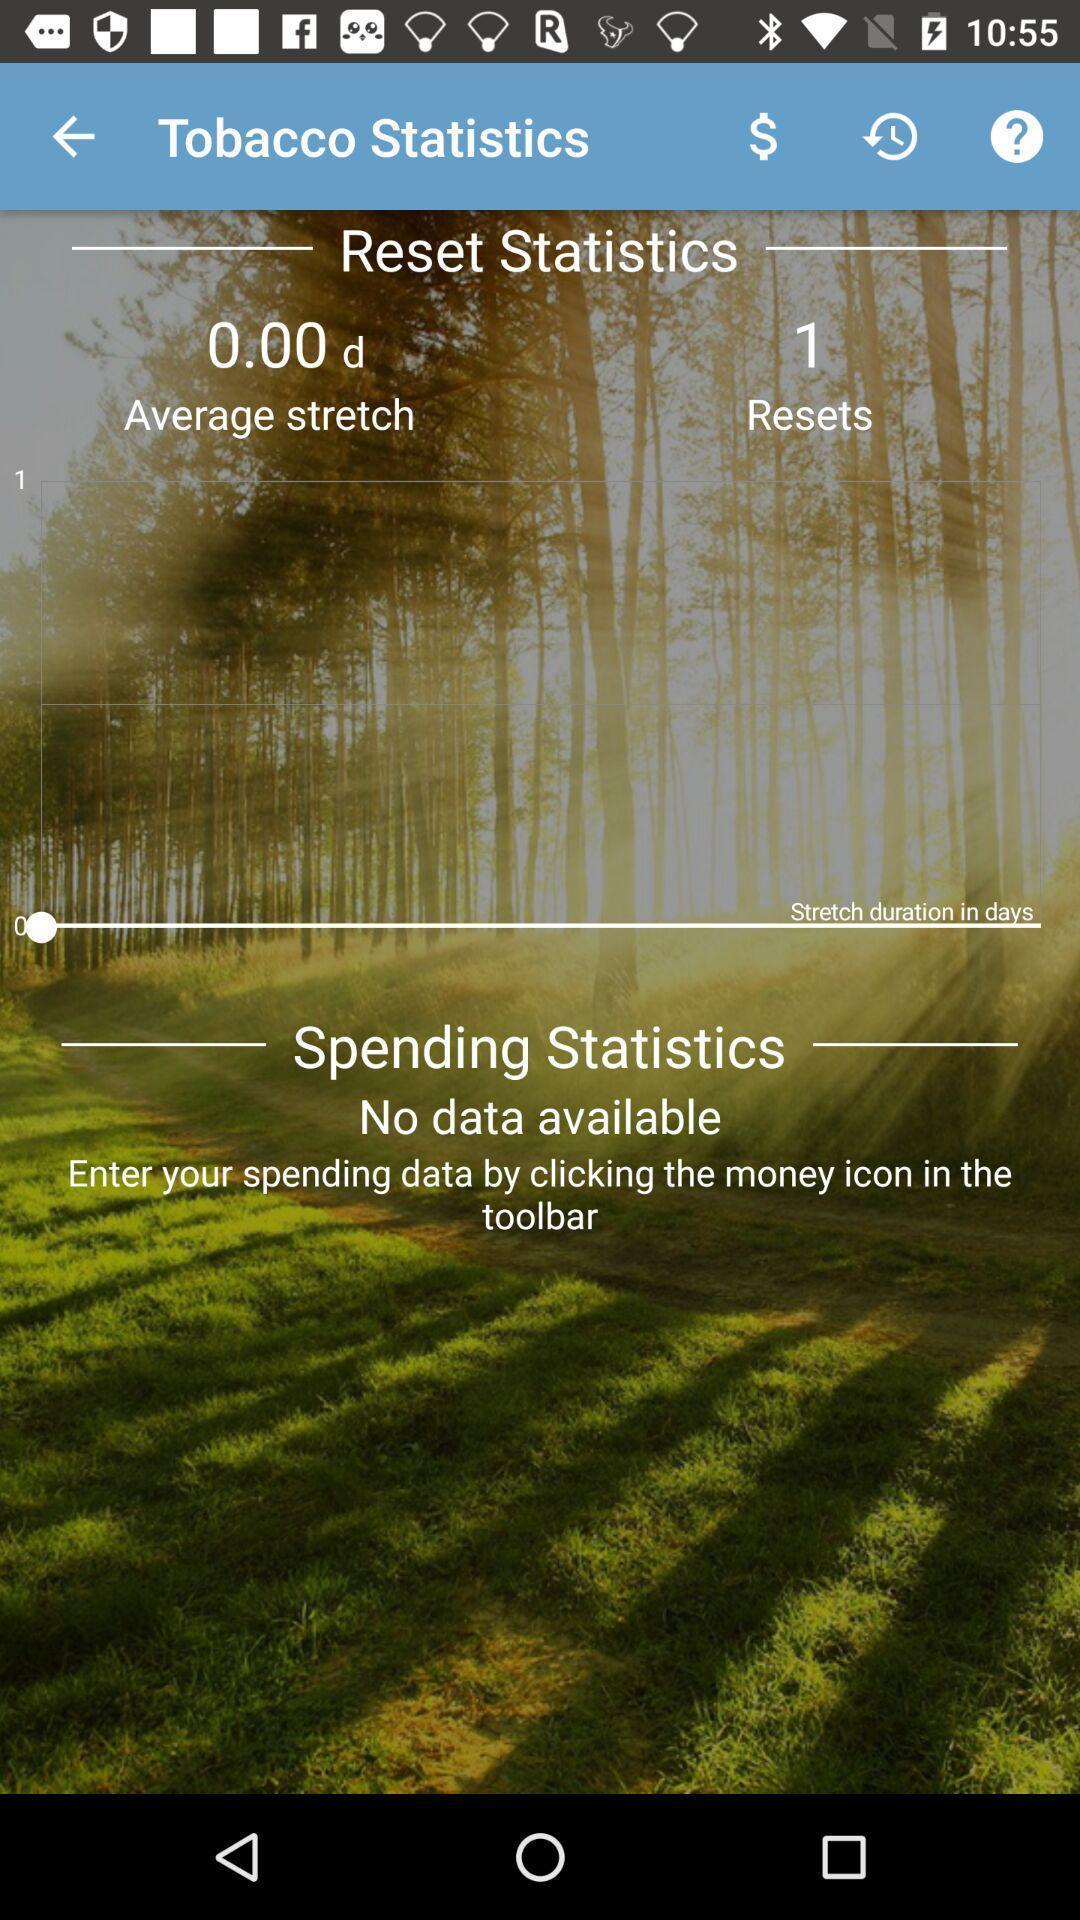Summarize the main components in this picture. Page shows the reset and spending statistics on motivational app. 